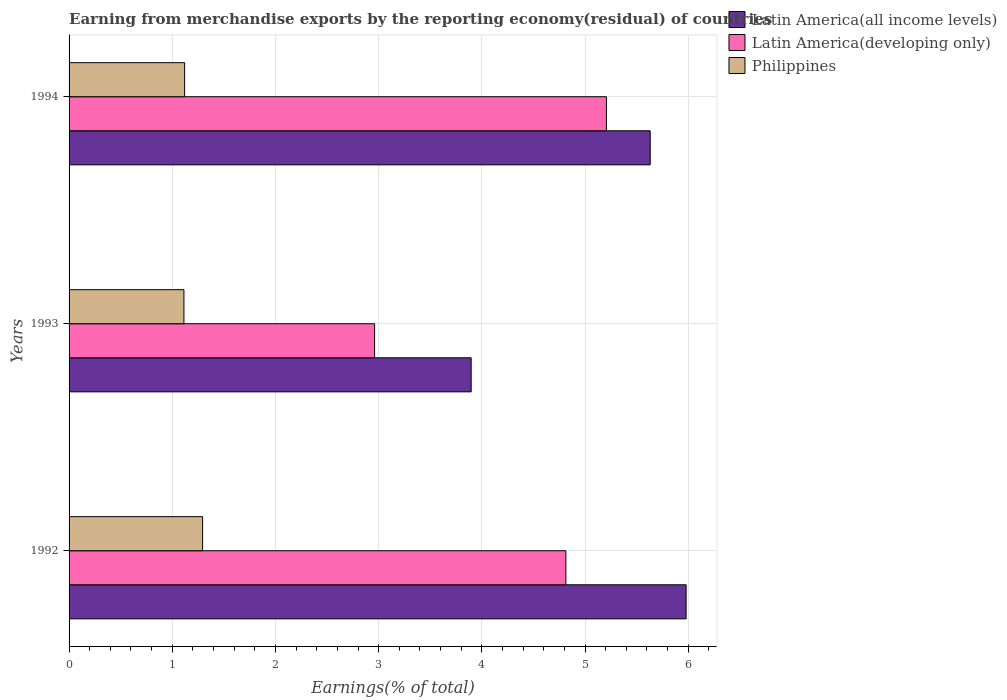How many different coloured bars are there?
Your answer should be compact. 3. How many groups of bars are there?
Your answer should be compact. 3. Are the number of bars per tick equal to the number of legend labels?
Offer a terse response. Yes. Are the number of bars on each tick of the Y-axis equal?
Provide a succinct answer. Yes. How many bars are there on the 1st tick from the top?
Your answer should be compact. 3. What is the percentage of amount earned from merchandise exports in Latin America(developing only) in 1993?
Give a very brief answer. 2.96. Across all years, what is the maximum percentage of amount earned from merchandise exports in Latin America(developing only)?
Offer a very short reply. 5.21. Across all years, what is the minimum percentage of amount earned from merchandise exports in Latin America(all income levels)?
Offer a very short reply. 3.9. In which year was the percentage of amount earned from merchandise exports in Latin America(developing only) minimum?
Your response must be concise. 1993. What is the total percentage of amount earned from merchandise exports in Philippines in the graph?
Offer a terse response. 3.53. What is the difference between the percentage of amount earned from merchandise exports in Philippines in 1992 and that in 1994?
Give a very brief answer. 0.17. What is the difference between the percentage of amount earned from merchandise exports in Latin America(developing only) in 1993 and the percentage of amount earned from merchandise exports in Latin America(all income levels) in 1992?
Ensure brevity in your answer.  -3.02. What is the average percentage of amount earned from merchandise exports in Latin America(developing only) per year?
Offer a very short reply. 4.33. In the year 1993, what is the difference between the percentage of amount earned from merchandise exports in Philippines and percentage of amount earned from merchandise exports in Latin America(developing only)?
Give a very brief answer. -1.85. What is the ratio of the percentage of amount earned from merchandise exports in Philippines in 1993 to that in 1994?
Your answer should be compact. 0.99. Is the difference between the percentage of amount earned from merchandise exports in Philippines in 1992 and 1994 greater than the difference between the percentage of amount earned from merchandise exports in Latin America(developing only) in 1992 and 1994?
Ensure brevity in your answer.  Yes. What is the difference between the highest and the second highest percentage of amount earned from merchandise exports in Latin America(all income levels)?
Provide a short and direct response. 0.35. What is the difference between the highest and the lowest percentage of amount earned from merchandise exports in Latin America(developing only)?
Make the answer very short. 2.25. What does the 3rd bar from the top in 1994 represents?
Your response must be concise. Latin America(all income levels). What does the 2nd bar from the bottom in 1993 represents?
Provide a short and direct response. Latin America(developing only). Are all the bars in the graph horizontal?
Ensure brevity in your answer.  Yes. How many years are there in the graph?
Your answer should be compact. 3. Are the values on the major ticks of X-axis written in scientific E-notation?
Your answer should be compact. No. How many legend labels are there?
Your response must be concise. 3. How are the legend labels stacked?
Offer a terse response. Vertical. What is the title of the graph?
Provide a succinct answer. Earning from merchandise exports by the reporting economy(residual) of countries. What is the label or title of the X-axis?
Ensure brevity in your answer.  Earnings(% of total). What is the Earnings(% of total) in Latin America(all income levels) in 1992?
Offer a terse response. 5.98. What is the Earnings(% of total) of Latin America(developing only) in 1992?
Your response must be concise. 4.81. What is the Earnings(% of total) in Philippines in 1992?
Your answer should be compact. 1.29. What is the Earnings(% of total) of Latin America(all income levels) in 1993?
Make the answer very short. 3.9. What is the Earnings(% of total) of Latin America(developing only) in 1993?
Provide a short and direct response. 2.96. What is the Earnings(% of total) in Philippines in 1993?
Keep it short and to the point. 1.11. What is the Earnings(% of total) in Latin America(all income levels) in 1994?
Offer a terse response. 5.63. What is the Earnings(% of total) of Latin America(developing only) in 1994?
Keep it short and to the point. 5.21. What is the Earnings(% of total) in Philippines in 1994?
Provide a succinct answer. 1.12. Across all years, what is the maximum Earnings(% of total) of Latin America(all income levels)?
Ensure brevity in your answer.  5.98. Across all years, what is the maximum Earnings(% of total) in Latin America(developing only)?
Your answer should be compact. 5.21. Across all years, what is the maximum Earnings(% of total) of Philippines?
Keep it short and to the point. 1.29. Across all years, what is the minimum Earnings(% of total) in Latin America(all income levels)?
Keep it short and to the point. 3.9. Across all years, what is the minimum Earnings(% of total) of Latin America(developing only)?
Provide a succinct answer. 2.96. Across all years, what is the minimum Earnings(% of total) in Philippines?
Your answer should be very brief. 1.11. What is the total Earnings(% of total) in Latin America(all income levels) in the graph?
Your answer should be very brief. 15.51. What is the total Earnings(% of total) of Latin America(developing only) in the graph?
Your answer should be very brief. 12.98. What is the total Earnings(% of total) of Philippines in the graph?
Your answer should be very brief. 3.53. What is the difference between the Earnings(% of total) in Latin America(all income levels) in 1992 and that in 1993?
Offer a very short reply. 2.08. What is the difference between the Earnings(% of total) of Latin America(developing only) in 1992 and that in 1993?
Ensure brevity in your answer.  1.85. What is the difference between the Earnings(% of total) of Philippines in 1992 and that in 1993?
Provide a short and direct response. 0.18. What is the difference between the Earnings(% of total) of Latin America(all income levels) in 1992 and that in 1994?
Keep it short and to the point. 0.35. What is the difference between the Earnings(% of total) in Latin America(developing only) in 1992 and that in 1994?
Offer a terse response. -0.39. What is the difference between the Earnings(% of total) in Philippines in 1992 and that in 1994?
Your answer should be compact. 0.17. What is the difference between the Earnings(% of total) of Latin America(all income levels) in 1993 and that in 1994?
Your answer should be compact. -1.74. What is the difference between the Earnings(% of total) in Latin America(developing only) in 1993 and that in 1994?
Provide a succinct answer. -2.25. What is the difference between the Earnings(% of total) of Philippines in 1993 and that in 1994?
Your answer should be very brief. -0.01. What is the difference between the Earnings(% of total) in Latin America(all income levels) in 1992 and the Earnings(% of total) in Latin America(developing only) in 1993?
Offer a terse response. 3.02. What is the difference between the Earnings(% of total) of Latin America(all income levels) in 1992 and the Earnings(% of total) of Philippines in 1993?
Give a very brief answer. 4.87. What is the difference between the Earnings(% of total) in Latin America(developing only) in 1992 and the Earnings(% of total) in Philippines in 1993?
Your answer should be very brief. 3.7. What is the difference between the Earnings(% of total) in Latin America(all income levels) in 1992 and the Earnings(% of total) in Latin America(developing only) in 1994?
Provide a short and direct response. 0.77. What is the difference between the Earnings(% of total) of Latin America(all income levels) in 1992 and the Earnings(% of total) of Philippines in 1994?
Give a very brief answer. 4.86. What is the difference between the Earnings(% of total) of Latin America(developing only) in 1992 and the Earnings(% of total) of Philippines in 1994?
Offer a terse response. 3.69. What is the difference between the Earnings(% of total) in Latin America(all income levels) in 1993 and the Earnings(% of total) in Latin America(developing only) in 1994?
Offer a very short reply. -1.31. What is the difference between the Earnings(% of total) in Latin America(all income levels) in 1993 and the Earnings(% of total) in Philippines in 1994?
Give a very brief answer. 2.78. What is the difference between the Earnings(% of total) of Latin America(developing only) in 1993 and the Earnings(% of total) of Philippines in 1994?
Provide a succinct answer. 1.84. What is the average Earnings(% of total) of Latin America(all income levels) per year?
Give a very brief answer. 5.17. What is the average Earnings(% of total) in Latin America(developing only) per year?
Give a very brief answer. 4.33. What is the average Earnings(% of total) of Philippines per year?
Offer a terse response. 1.18. In the year 1992, what is the difference between the Earnings(% of total) in Latin America(all income levels) and Earnings(% of total) in Latin America(developing only)?
Ensure brevity in your answer.  1.16. In the year 1992, what is the difference between the Earnings(% of total) of Latin America(all income levels) and Earnings(% of total) of Philippines?
Your response must be concise. 4.69. In the year 1992, what is the difference between the Earnings(% of total) in Latin America(developing only) and Earnings(% of total) in Philippines?
Your answer should be very brief. 3.52. In the year 1993, what is the difference between the Earnings(% of total) in Latin America(all income levels) and Earnings(% of total) in Latin America(developing only)?
Offer a very short reply. 0.94. In the year 1993, what is the difference between the Earnings(% of total) of Latin America(all income levels) and Earnings(% of total) of Philippines?
Offer a terse response. 2.78. In the year 1993, what is the difference between the Earnings(% of total) in Latin America(developing only) and Earnings(% of total) in Philippines?
Ensure brevity in your answer.  1.85. In the year 1994, what is the difference between the Earnings(% of total) of Latin America(all income levels) and Earnings(% of total) of Latin America(developing only)?
Keep it short and to the point. 0.42. In the year 1994, what is the difference between the Earnings(% of total) of Latin America(all income levels) and Earnings(% of total) of Philippines?
Make the answer very short. 4.51. In the year 1994, what is the difference between the Earnings(% of total) in Latin America(developing only) and Earnings(% of total) in Philippines?
Provide a succinct answer. 4.09. What is the ratio of the Earnings(% of total) of Latin America(all income levels) in 1992 to that in 1993?
Keep it short and to the point. 1.53. What is the ratio of the Earnings(% of total) in Latin America(developing only) in 1992 to that in 1993?
Give a very brief answer. 1.63. What is the ratio of the Earnings(% of total) in Philippines in 1992 to that in 1993?
Provide a short and direct response. 1.16. What is the ratio of the Earnings(% of total) of Latin America(all income levels) in 1992 to that in 1994?
Keep it short and to the point. 1.06. What is the ratio of the Earnings(% of total) of Latin America(developing only) in 1992 to that in 1994?
Ensure brevity in your answer.  0.92. What is the ratio of the Earnings(% of total) in Philippines in 1992 to that in 1994?
Offer a very short reply. 1.16. What is the ratio of the Earnings(% of total) of Latin America(all income levels) in 1993 to that in 1994?
Offer a terse response. 0.69. What is the ratio of the Earnings(% of total) of Latin America(developing only) in 1993 to that in 1994?
Ensure brevity in your answer.  0.57. What is the ratio of the Earnings(% of total) of Philippines in 1993 to that in 1994?
Make the answer very short. 0.99. What is the difference between the highest and the second highest Earnings(% of total) in Latin America(all income levels)?
Provide a short and direct response. 0.35. What is the difference between the highest and the second highest Earnings(% of total) of Latin America(developing only)?
Offer a terse response. 0.39. What is the difference between the highest and the second highest Earnings(% of total) of Philippines?
Your response must be concise. 0.17. What is the difference between the highest and the lowest Earnings(% of total) of Latin America(all income levels)?
Your answer should be very brief. 2.08. What is the difference between the highest and the lowest Earnings(% of total) in Latin America(developing only)?
Provide a short and direct response. 2.25. What is the difference between the highest and the lowest Earnings(% of total) of Philippines?
Your response must be concise. 0.18. 